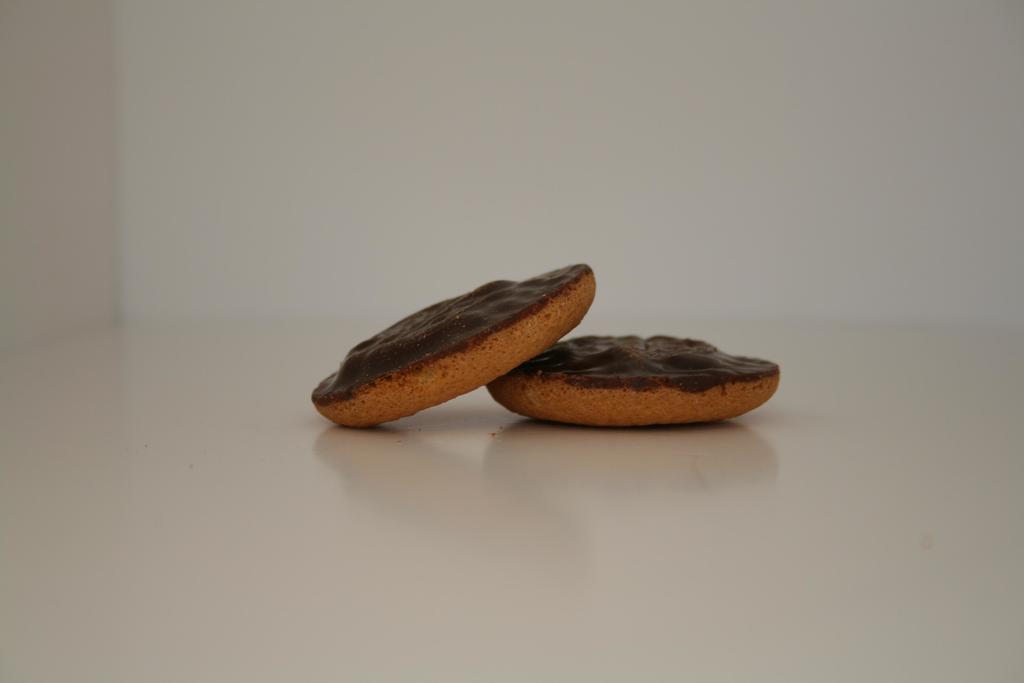Could you give a brief overview of what you see in this image? In this image we can see biscuits on a platform. 